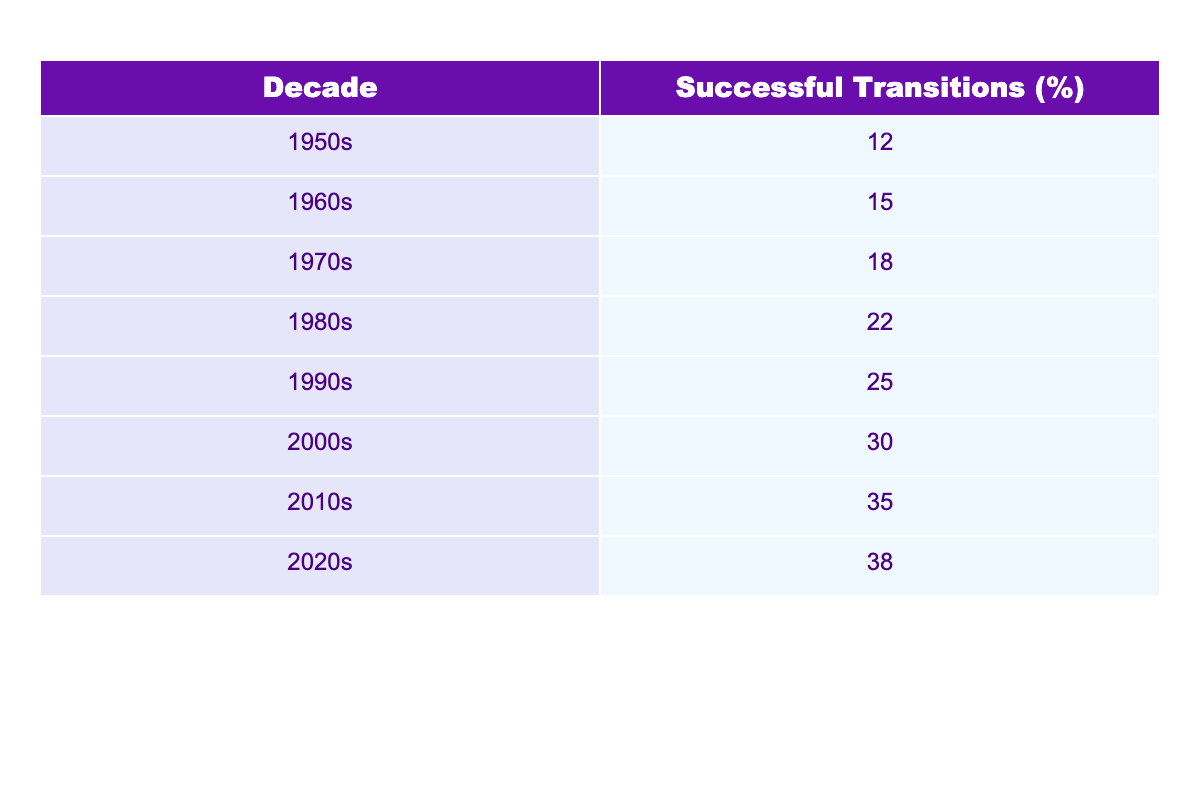What was the percentage of successful career transitions for child actors in the 1990s? According to the table, the percentage of successful transitions in the 1990s was listed directly as 25%.
Answer: 25% Which decade had the highest percentage of successful transitions? By comparing the values across all decades, the decade with the highest percentage is the 2020s, which had 38%.
Answer: 2020s What is the difference in successful transitions from the 1950s to the 2020s? The successful transitions in the 1950s were 12% and in the 2020s it is 38%. The difference is calculated as 38% - 12% = 26%.
Answer: 26% What is the average percentage of successful transitions across the decades from the 1950s to the 2010s? First, sum all the percentages from the 1950s to the 2010s: 12 + 15 + 18 + 22 + 25 + 30 + 35 =  127. There are 7 decades, so the average is 127 / 7 ≈ 18.14%.
Answer: 18.14% Is it true that more than 30% of child actors successfully transitioned to adult roles in the 2000s? The percentage of successful transitions in the 2000s is 30%, which means it is not more than 30%. Therefore, the statement is false.
Answer: False How much did the percentage of successful transitions increase from the 1980s to the 2010s? The successful transitions in the 1980s were 22% and in the 2010s it is 35%. The increase is 35% - 22% = 13%.
Answer: 13% Which decade saw a smaller percentage increase: the 1960s to the 1970s, or the 2000s to the 2010s? The increase from the 1960s to the 1970s is 18% - 15% = 3% and from the 2000s to the 2010s is 35% - 30% = 5%. Thus, the smaller increase was from the 1960s to the 1970s.
Answer: 1960s to the 1970s What percentage of successful career transitions did child actors achieve by the end of the 2010s, and how does it compare to the 1980s? By the end of the 2010s, the percentage was 35%, while in the 1980s it was 22%. The comparison shows an increase of 35% - 22% = 13%.
Answer: 13% increase from 1980s to 2010s 